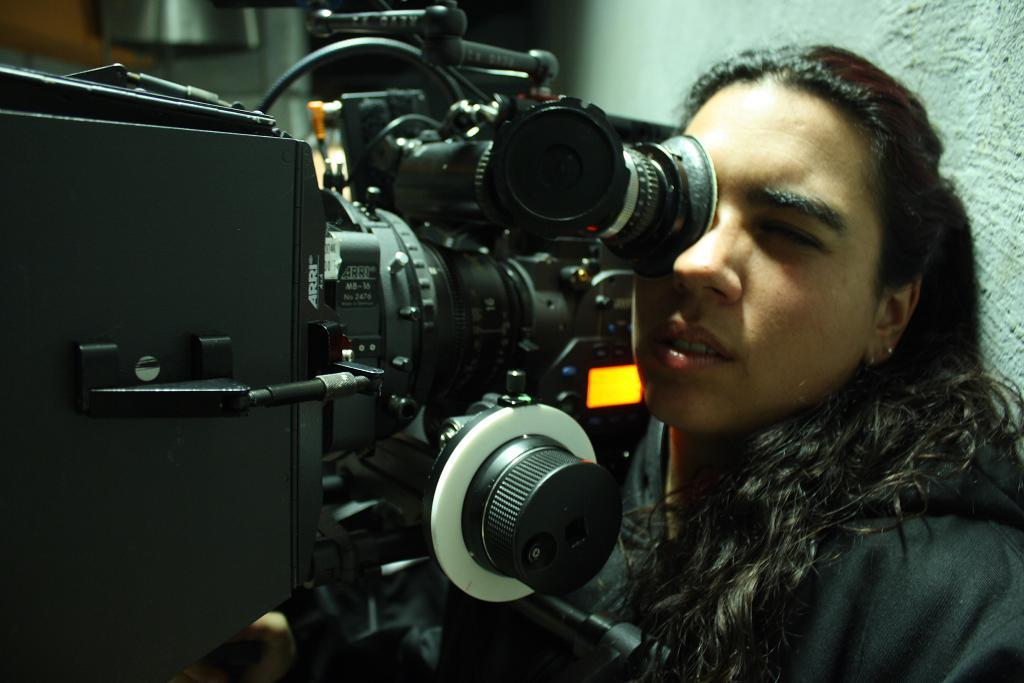Who is the main subject in the image? There is a woman in the image. What is the woman wearing? The woman is wearing a black dress. What can be seen besides the woman in the image? There is a huge camera in the image. What is the color of the camera? The camera is black in color. Where is the camera positioned in relation to the woman? The camera is in front of the woman. What is visible in the background of the image? There is a white-colored wall in the background of the image. What type of crack is visible on the woman's dress in the image? There is no crack visible on the woman's dress in the image. What nation is represented by the woman in the image? The image does not provide any information about the woman's nationality. 